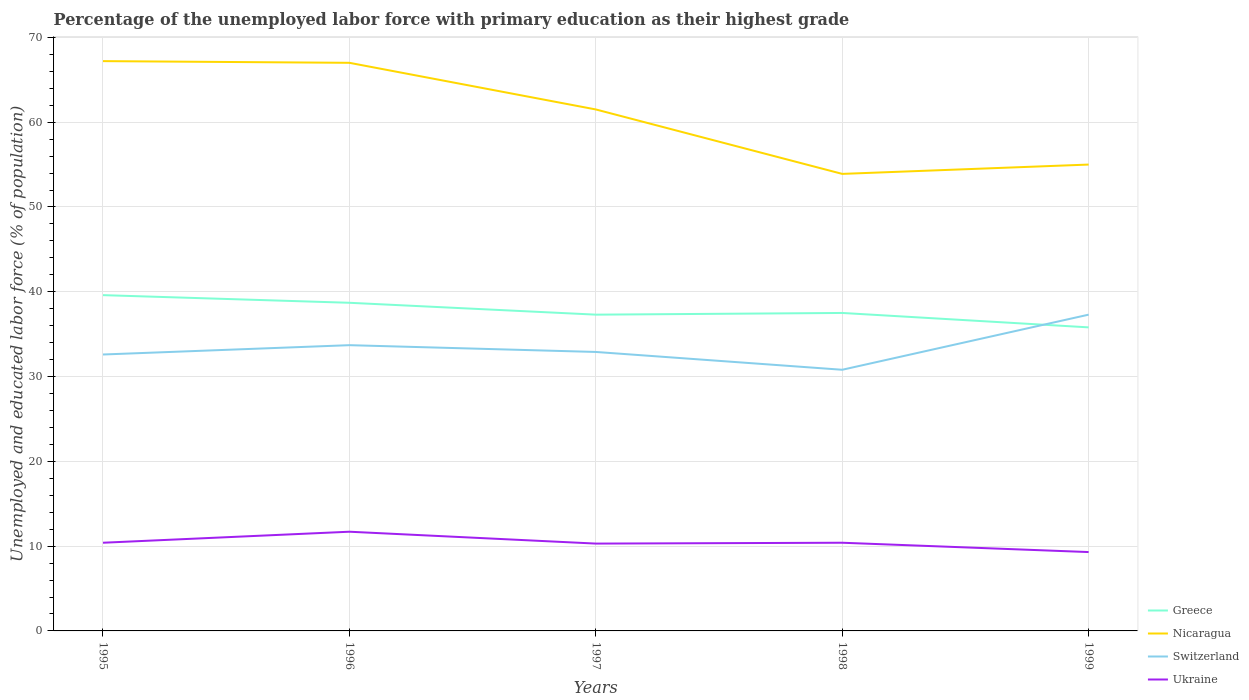Across all years, what is the maximum percentage of the unemployed labor force with primary education in Nicaragua?
Provide a short and direct response. 53.9. What is the total percentage of the unemployed labor force with primary education in Ukraine in the graph?
Your answer should be compact. 0.1. What is the difference between the highest and the second highest percentage of the unemployed labor force with primary education in Switzerland?
Your answer should be very brief. 6.5. What is the difference between the highest and the lowest percentage of the unemployed labor force with primary education in Ukraine?
Your response must be concise. 1. How many lines are there?
Offer a terse response. 4. How many years are there in the graph?
Offer a terse response. 5. Are the values on the major ticks of Y-axis written in scientific E-notation?
Offer a very short reply. No. Where does the legend appear in the graph?
Your answer should be very brief. Bottom right. What is the title of the graph?
Provide a short and direct response. Percentage of the unemployed labor force with primary education as their highest grade. Does "Burkina Faso" appear as one of the legend labels in the graph?
Provide a short and direct response. No. What is the label or title of the Y-axis?
Your answer should be very brief. Unemployed and educated labor force (% of population). What is the Unemployed and educated labor force (% of population) of Greece in 1995?
Make the answer very short. 39.6. What is the Unemployed and educated labor force (% of population) in Nicaragua in 1995?
Provide a succinct answer. 67.2. What is the Unemployed and educated labor force (% of population) in Switzerland in 1995?
Your answer should be very brief. 32.6. What is the Unemployed and educated labor force (% of population) of Ukraine in 1995?
Provide a succinct answer. 10.4. What is the Unemployed and educated labor force (% of population) of Greece in 1996?
Offer a terse response. 38.7. What is the Unemployed and educated labor force (% of population) in Nicaragua in 1996?
Your answer should be compact. 67. What is the Unemployed and educated labor force (% of population) of Switzerland in 1996?
Offer a very short reply. 33.7. What is the Unemployed and educated labor force (% of population) in Ukraine in 1996?
Offer a terse response. 11.7. What is the Unemployed and educated labor force (% of population) of Greece in 1997?
Your response must be concise. 37.3. What is the Unemployed and educated labor force (% of population) in Nicaragua in 1997?
Ensure brevity in your answer.  61.5. What is the Unemployed and educated labor force (% of population) in Switzerland in 1997?
Ensure brevity in your answer.  32.9. What is the Unemployed and educated labor force (% of population) of Ukraine in 1997?
Ensure brevity in your answer.  10.3. What is the Unemployed and educated labor force (% of population) in Greece in 1998?
Make the answer very short. 37.5. What is the Unemployed and educated labor force (% of population) in Nicaragua in 1998?
Provide a succinct answer. 53.9. What is the Unemployed and educated labor force (% of population) in Switzerland in 1998?
Make the answer very short. 30.8. What is the Unemployed and educated labor force (% of population) in Ukraine in 1998?
Offer a very short reply. 10.4. What is the Unemployed and educated labor force (% of population) of Greece in 1999?
Offer a very short reply. 35.8. What is the Unemployed and educated labor force (% of population) of Nicaragua in 1999?
Your answer should be compact. 55. What is the Unemployed and educated labor force (% of population) of Switzerland in 1999?
Provide a succinct answer. 37.3. What is the Unemployed and educated labor force (% of population) in Ukraine in 1999?
Provide a succinct answer. 9.3. Across all years, what is the maximum Unemployed and educated labor force (% of population) in Greece?
Provide a short and direct response. 39.6. Across all years, what is the maximum Unemployed and educated labor force (% of population) in Nicaragua?
Offer a terse response. 67.2. Across all years, what is the maximum Unemployed and educated labor force (% of population) in Switzerland?
Your response must be concise. 37.3. Across all years, what is the maximum Unemployed and educated labor force (% of population) in Ukraine?
Offer a terse response. 11.7. Across all years, what is the minimum Unemployed and educated labor force (% of population) in Greece?
Your response must be concise. 35.8. Across all years, what is the minimum Unemployed and educated labor force (% of population) of Nicaragua?
Your answer should be compact. 53.9. Across all years, what is the minimum Unemployed and educated labor force (% of population) of Switzerland?
Keep it short and to the point. 30.8. Across all years, what is the minimum Unemployed and educated labor force (% of population) in Ukraine?
Offer a terse response. 9.3. What is the total Unemployed and educated labor force (% of population) in Greece in the graph?
Offer a very short reply. 188.9. What is the total Unemployed and educated labor force (% of population) in Nicaragua in the graph?
Keep it short and to the point. 304.6. What is the total Unemployed and educated labor force (% of population) of Switzerland in the graph?
Make the answer very short. 167.3. What is the total Unemployed and educated labor force (% of population) in Ukraine in the graph?
Your response must be concise. 52.1. What is the difference between the Unemployed and educated labor force (% of population) of Nicaragua in 1995 and that in 1996?
Give a very brief answer. 0.2. What is the difference between the Unemployed and educated labor force (% of population) of Ukraine in 1995 and that in 1996?
Offer a terse response. -1.3. What is the difference between the Unemployed and educated labor force (% of population) of Greece in 1995 and that in 1997?
Your response must be concise. 2.3. What is the difference between the Unemployed and educated labor force (% of population) of Switzerland in 1995 and that in 1997?
Give a very brief answer. -0.3. What is the difference between the Unemployed and educated labor force (% of population) of Ukraine in 1995 and that in 1997?
Give a very brief answer. 0.1. What is the difference between the Unemployed and educated labor force (% of population) in Switzerland in 1995 and that in 1998?
Make the answer very short. 1.8. What is the difference between the Unemployed and educated labor force (% of population) in Greece in 1995 and that in 1999?
Give a very brief answer. 3.8. What is the difference between the Unemployed and educated labor force (% of population) of Switzerland in 1995 and that in 1999?
Give a very brief answer. -4.7. What is the difference between the Unemployed and educated labor force (% of population) in Ukraine in 1995 and that in 1999?
Provide a short and direct response. 1.1. What is the difference between the Unemployed and educated labor force (% of population) in Switzerland in 1996 and that in 1997?
Make the answer very short. 0.8. What is the difference between the Unemployed and educated labor force (% of population) in Ukraine in 1996 and that in 1997?
Offer a terse response. 1.4. What is the difference between the Unemployed and educated labor force (% of population) in Greece in 1996 and that in 1998?
Give a very brief answer. 1.2. What is the difference between the Unemployed and educated labor force (% of population) in Nicaragua in 1996 and that in 1998?
Offer a terse response. 13.1. What is the difference between the Unemployed and educated labor force (% of population) in Switzerland in 1996 and that in 1998?
Ensure brevity in your answer.  2.9. What is the difference between the Unemployed and educated labor force (% of population) of Ukraine in 1996 and that in 1998?
Offer a terse response. 1.3. What is the difference between the Unemployed and educated labor force (% of population) of Nicaragua in 1996 and that in 1999?
Offer a terse response. 12. What is the difference between the Unemployed and educated labor force (% of population) in Greece in 1997 and that in 1998?
Provide a short and direct response. -0.2. What is the difference between the Unemployed and educated labor force (% of population) of Ukraine in 1997 and that in 1998?
Provide a succinct answer. -0.1. What is the difference between the Unemployed and educated labor force (% of population) of Ukraine in 1997 and that in 1999?
Provide a short and direct response. 1. What is the difference between the Unemployed and educated labor force (% of population) in Greece in 1995 and the Unemployed and educated labor force (% of population) in Nicaragua in 1996?
Make the answer very short. -27.4. What is the difference between the Unemployed and educated labor force (% of population) of Greece in 1995 and the Unemployed and educated labor force (% of population) of Ukraine in 1996?
Keep it short and to the point. 27.9. What is the difference between the Unemployed and educated labor force (% of population) of Nicaragua in 1995 and the Unemployed and educated labor force (% of population) of Switzerland in 1996?
Give a very brief answer. 33.5. What is the difference between the Unemployed and educated labor force (% of population) in Nicaragua in 1995 and the Unemployed and educated labor force (% of population) in Ukraine in 1996?
Keep it short and to the point. 55.5. What is the difference between the Unemployed and educated labor force (% of population) of Switzerland in 1995 and the Unemployed and educated labor force (% of population) of Ukraine in 1996?
Your answer should be very brief. 20.9. What is the difference between the Unemployed and educated labor force (% of population) of Greece in 1995 and the Unemployed and educated labor force (% of population) of Nicaragua in 1997?
Make the answer very short. -21.9. What is the difference between the Unemployed and educated labor force (% of population) of Greece in 1995 and the Unemployed and educated labor force (% of population) of Switzerland in 1997?
Keep it short and to the point. 6.7. What is the difference between the Unemployed and educated labor force (% of population) of Greece in 1995 and the Unemployed and educated labor force (% of population) of Ukraine in 1997?
Provide a short and direct response. 29.3. What is the difference between the Unemployed and educated labor force (% of population) of Nicaragua in 1995 and the Unemployed and educated labor force (% of population) of Switzerland in 1997?
Your answer should be compact. 34.3. What is the difference between the Unemployed and educated labor force (% of population) in Nicaragua in 1995 and the Unemployed and educated labor force (% of population) in Ukraine in 1997?
Your answer should be very brief. 56.9. What is the difference between the Unemployed and educated labor force (% of population) in Switzerland in 1995 and the Unemployed and educated labor force (% of population) in Ukraine in 1997?
Make the answer very short. 22.3. What is the difference between the Unemployed and educated labor force (% of population) in Greece in 1995 and the Unemployed and educated labor force (% of population) in Nicaragua in 1998?
Your response must be concise. -14.3. What is the difference between the Unemployed and educated labor force (% of population) in Greece in 1995 and the Unemployed and educated labor force (% of population) in Ukraine in 1998?
Give a very brief answer. 29.2. What is the difference between the Unemployed and educated labor force (% of population) of Nicaragua in 1995 and the Unemployed and educated labor force (% of population) of Switzerland in 1998?
Ensure brevity in your answer.  36.4. What is the difference between the Unemployed and educated labor force (% of population) in Nicaragua in 1995 and the Unemployed and educated labor force (% of population) in Ukraine in 1998?
Your response must be concise. 56.8. What is the difference between the Unemployed and educated labor force (% of population) in Switzerland in 1995 and the Unemployed and educated labor force (% of population) in Ukraine in 1998?
Your response must be concise. 22.2. What is the difference between the Unemployed and educated labor force (% of population) of Greece in 1995 and the Unemployed and educated labor force (% of population) of Nicaragua in 1999?
Provide a succinct answer. -15.4. What is the difference between the Unemployed and educated labor force (% of population) of Greece in 1995 and the Unemployed and educated labor force (% of population) of Ukraine in 1999?
Keep it short and to the point. 30.3. What is the difference between the Unemployed and educated labor force (% of population) of Nicaragua in 1995 and the Unemployed and educated labor force (% of population) of Switzerland in 1999?
Provide a short and direct response. 29.9. What is the difference between the Unemployed and educated labor force (% of population) in Nicaragua in 1995 and the Unemployed and educated labor force (% of population) in Ukraine in 1999?
Make the answer very short. 57.9. What is the difference between the Unemployed and educated labor force (% of population) in Switzerland in 1995 and the Unemployed and educated labor force (% of population) in Ukraine in 1999?
Offer a very short reply. 23.3. What is the difference between the Unemployed and educated labor force (% of population) in Greece in 1996 and the Unemployed and educated labor force (% of population) in Nicaragua in 1997?
Provide a succinct answer. -22.8. What is the difference between the Unemployed and educated labor force (% of population) in Greece in 1996 and the Unemployed and educated labor force (% of population) in Ukraine in 1997?
Provide a succinct answer. 28.4. What is the difference between the Unemployed and educated labor force (% of population) of Nicaragua in 1996 and the Unemployed and educated labor force (% of population) of Switzerland in 1997?
Keep it short and to the point. 34.1. What is the difference between the Unemployed and educated labor force (% of population) of Nicaragua in 1996 and the Unemployed and educated labor force (% of population) of Ukraine in 1997?
Your response must be concise. 56.7. What is the difference between the Unemployed and educated labor force (% of population) of Switzerland in 1996 and the Unemployed and educated labor force (% of population) of Ukraine in 1997?
Keep it short and to the point. 23.4. What is the difference between the Unemployed and educated labor force (% of population) of Greece in 1996 and the Unemployed and educated labor force (% of population) of Nicaragua in 1998?
Provide a succinct answer. -15.2. What is the difference between the Unemployed and educated labor force (% of population) in Greece in 1996 and the Unemployed and educated labor force (% of population) in Switzerland in 1998?
Your answer should be compact. 7.9. What is the difference between the Unemployed and educated labor force (% of population) of Greece in 1996 and the Unemployed and educated labor force (% of population) of Ukraine in 1998?
Offer a very short reply. 28.3. What is the difference between the Unemployed and educated labor force (% of population) of Nicaragua in 1996 and the Unemployed and educated labor force (% of population) of Switzerland in 1998?
Provide a short and direct response. 36.2. What is the difference between the Unemployed and educated labor force (% of population) of Nicaragua in 1996 and the Unemployed and educated labor force (% of population) of Ukraine in 1998?
Provide a succinct answer. 56.6. What is the difference between the Unemployed and educated labor force (% of population) in Switzerland in 1996 and the Unemployed and educated labor force (% of population) in Ukraine in 1998?
Give a very brief answer. 23.3. What is the difference between the Unemployed and educated labor force (% of population) of Greece in 1996 and the Unemployed and educated labor force (% of population) of Nicaragua in 1999?
Make the answer very short. -16.3. What is the difference between the Unemployed and educated labor force (% of population) of Greece in 1996 and the Unemployed and educated labor force (% of population) of Ukraine in 1999?
Keep it short and to the point. 29.4. What is the difference between the Unemployed and educated labor force (% of population) of Nicaragua in 1996 and the Unemployed and educated labor force (% of population) of Switzerland in 1999?
Your answer should be very brief. 29.7. What is the difference between the Unemployed and educated labor force (% of population) in Nicaragua in 1996 and the Unemployed and educated labor force (% of population) in Ukraine in 1999?
Offer a very short reply. 57.7. What is the difference between the Unemployed and educated labor force (% of population) of Switzerland in 1996 and the Unemployed and educated labor force (% of population) of Ukraine in 1999?
Make the answer very short. 24.4. What is the difference between the Unemployed and educated labor force (% of population) of Greece in 1997 and the Unemployed and educated labor force (% of population) of Nicaragua in 1998?
Your answer should be very brief. -16.6. What is the difference between the Unemployed and educated labor force (% of population) of Greece in 1997 and the Unemployed and educated labor force (% of population) of Switzerland in 1998?
Give a very brief answer. 6.5. What is the difference between the Unemployed and educated labor force (% of population) of Greece in 1997 and the Unemployed and educated labor force (% of population) of Ukraine in 1998?
Offer a very short reply. 26.9. What is the difference between the Unemployed and educated labor force (% of population) in Nicaragua in 1997 and the Unemployed and educated labor force (% of population) in Switzerland in 1998?
Keep it short and to the point. 30.7. What is the difference between the Unemployed and educated labor force (% of population) in Nicaragua in 1997 and the Unemployed and educated labor force (% of population) in Ukraine in 1998?
Make the answer very short. 51.1. What is the difference between the Unemployed and educated labor force (% of population) of Greece in 1997 and the Unemployed and educated labor force (% of population) of Nicaragua in 1999?
Offer a terse response. -17.7. What is the difference between the Unemployed and educated labor force (% of population) in Nicaragua in 1997 and the Unemployed and educated labor force (% of population) in Switzerland in 1999?
Your answer should be compact. 24.2. What is the difference between the Unemployed and educated labor force (% of population) in Nicaragua in 1997 and the Unemployed and educated labor force (% of population) in Ukraine in 1999?
Offer a very short reply. 52.2. What is the difference between the Unemployed and educated labor force (% of population) of Switzerland in 1997 and the Unemployed and educated labor force (% of population) of Ukraine in 1999?
Make the answer very short. 23.6. What is the difference between the Unemployed and educated labor force (% of population) in Greece in 1998 and the Unemployed and educated labor force (% of population) in Nicaragua in 1999?
Provide a short and direct response. -17.5. What is the difference between the Unemployed and educated labor force (% of population) in Greece in 1998 and the Unemployed and educated labor force (% of population) in Ukraine in 1999?
Keep it short and to the point. 28.2. What is the difference between the Unemployed and educated labor force (% of population) in Nicaragua in 1998 and the Unemployed and educated labor force (% of population) in Ukraine in 1999?
Provide a succinct answer. 44.6. What is the average Unemployed and educated labor force (% of population) of Greece per year?
Keep it short and to the point. 37.78. What is the average Unemployed and educated labor force (% of population) in Nicaragua per year?
Provide a short and direct response. 60.92. What is the average Unemployed and educated labor force (% of population) of Switzerland per year?
Provide a short and direct response. 33.46. What is the average Unemployed and educated labor force (% of population) in Ukraine per year?
Offer a very short reply. 10.42. In the year 1995, what is the difference between the Unemployed and educated labor force (% of population) in Greece and Unemployed and educated labor force (% of population) in Nicaragua?
Make the answer very short. -27.6. In the year 1995, what is the difference between the Unemployed and educated labor force (% of population) of Greece and Unemployed and educated labor force (% of population) of Ukraine?
Keep it short and to the point. 29.2. In the year 1995, what is the difference between the Unemployed and educated labor force (% of population) in Nicaragua and Unemployed and educated labor force (% of population) in Switzerland?
Keep it short and to the point. 34.6. In the year 1995, what is the difference between the Unemployed and educated labor force (% of population) of Nicaragua and Unemployed and educated labor force (% of population) of Ukraine?
Provide a succinct answer. 56.8. In the year 1996, what is the difference between the Unemployed and educated labor force (% of population) of Greece and Unemployed and educated labor force (% of population) of Nicaragua?
Give a very brief answer. -28.3. In the year 1996, what is the difference between the Unemployed and educated labor force (% of population) in Greece and Unemployed and educated labor force (% of population) in Switzerland?
Your answer should be very brief. 5. In the year 1996, what is the difference between the Unemployed and educated labor force (% of population) of Nicaragua and Unemployed and educated labor force (% of population) of Switzerland?
Your response must be concise. 33.3. In the year 1996, what is the difference between the Unemployed and educated labor force (% of population) of Nicaragua and Unemployed and educated labor force (% of population) of Ukraine?
Offer a terse response. 55.3. In the year 1996, what is the difference between the Unemployed and educated labor force (% of population) of Switzerland and Unemployed and educated labor force (% of population) of Ukraine?
Provide a succinct answer. 22. In the year 1997, what is the difference between the Unemployed and educated labor force (% of population) of Greece and Unemployed and educated labor force (% of population) of Nicaragua?
Your answer should be compact. -24.2. In the year 1997, what is the difference between the Unemployed and educated labor force (% of population) in Greece and Unemployed and educated labor force (% of population) in Switzerland?
Offer a very short reply. 4.4. In the year 1997, what is the difference between the Unemployed and educated labor force (% of population) in Greece and Unemployed and educated labor force (% of population) in Ukraine?
Give a very brief answer. 27. In the year 1997, what is the difference between the Unemployed and educated labor force (% of population) in Nicaragua and Unemployed and educated labor force (% of population) in Switzerland?
Provide a short and direct response. 28.6. In the year 1997, what is the difference between the Unemployed and educated labor force (% of population) of Nicaragua and Unemployed and educated labor force (% of population) of Ukraine?
Provide a succinct answer. 51.2. In the year 1997, what is the difference between the Unemployed and educated labor force (% of population) of Switzerland and Unemployed and educated labor force (% of population) of Ukraine?
Offer a terse response. 22.6. In the year 1998, what is the difference between the Unemployed and educated labor force (% of population) of Greece and Unemployed and educated labor force (% of population) of Nicaragua?
Keep it short and to the point. -16.4. In the year 1998, what is the difference between the Unemployed and educated labor force (% of population) in Greece and Unemployed and educated labor force (% of population) in Switzerland?
Offer a very short reply. 6.7. In the year 1998, what is the difference between the Unemployed and educated labor force (% of population) in Greece and Unemployed and educated labor force (% of population) in Ukraine?
Make the answer very short. 27.1. In the year 1998, what is the difference between the Unemployed and educated labor force (% of population) of Nicaragua and Unemployed and educated labor force (% of population) of Switzerland?
Keep it short and to the point. 23.1. In the year 1998, what is the difference between the Unemployed and educated labor force (% of population) of Nicaragua and Unemployed and educated labor force (% of population) of Ukraine?
Provide a succinct answer. 43.5. In the year 1998, what is the difference between the Unemployed and educated labor force (% of population) of Switzerland and Unemployed and educated labor force (% of population) of Ukraine?
Provide a short and direct response. 20.4. In the year 1999, what is the difference between the Unemployed and educated labor force (% of population) in Greece and Unemployed and educated labor force (% of population) in Nicaragua?
Provide a short and direct response. -19.2. In the year 1999, what is the difference between the Unemployed and educated labor force (% of population) of Nicaragua and Unemployed and educated labor force (% of population) of Switzerland?
Offer a very short reply. 17.7. In the year 1999, what is the difference between the Unemployed and educated labor force (% of population) in Nicaragua and Unemployed and educated labor force (% of population) in Ukraine?
Offer a terse response. 45.7. What is the ratio of the Unemployed and educated labor force (% of population) in Greece in 1995 to that in 1996?
Make the answer very short. 1.02. What is the ratio of the Unemployed and educated labor force (% of population) in Nicaragua in 1995 to that in 1996?
Ensure brevity in your answer.  1. What is the ratio of the Unemployed and educated labor force (% of population) of Switzerland in 1995 to that in 1996?
Your response must be concise. 0.97. What is the ratio of the Unemployed and educated labor force (% of population) in Greece in 1995 to that in 1997?
Provide a short and direct response. 1.06. What is the ratio of the Unemployed and educated labor force (% of population) of Nicaragua in 1995 to that in 1997?
Provide a short and direct response. 1.09. What is the ratio of the Unemployed and educated labor force (% of population) in Switzerland in 1995 to that in 1997?
Give a very brief answer. 0.99. What is the ratio of the Unemployed and educated labor force (% of population) of Ukraine in 1995 to that in 1997?
Offer a very short reply. 1.01. What is the ratio of the Unemployed and educated labor force (% of population) of Greece in 1995 to that in 1998?
Provide a short and direct response. 1.06. What is the ratio of the Unemployed and educated labor force (% of population) in Nicaragua in 1995 to that in 1998?
Your answer should be compact. 1.25. What is the ratio of the Unemployed and educated labor force (% of population) in Switzerland in 1995 to that in 1998?
Offer a terse response. 1.06. What is the ratio of the Unemployed and educated labor force (% of population) of Ukraine in 1995 to that in 1998?
Provide a succinct answer. 1. What is the ratio of the Unemployed and educated labor force (% of population) of Greece in 1995 to that in 1999?
Provide a succinct answer. 1.11. What is the ratio of the Unemployed and educated labor force (% of population) of Nicaragua in 1995 to that in 1999?
Make the answer very short. 1.22. What is the ratio of the Unemployed and educated labor force (% of population) of Switzerland in 1995 to that in 1999?
Make the answer very short. 0.87. What is the ratio of the Unemployed and educated labor force (% of population) of Ukraine in 1995 to that in 1999?
Your answer should be very brief. 1.12. What is the ratio of the Unemployed and educated labor force (% of population) of Greece in 1996 to that in 1997?
Offer a terse response. 1.04. What is the ratio of the Unemployed and educated labor force (% of population) in Nicaragua in 1996 to that in 1997?
Give a very brief answer. 1.09. What is the ratio of the Unemployed and educated labor force (% of population) of Switzerland in 1996 to that in 1997?
Your answer should be very brief. 1.02. What is the ratio of the Unemployed and educated labor force (% of population) in Ukraine in 1996 to that in 1997?
Provide a short and direct response. 1.14. What is the ratio of the Unemployed and educated labor force (% of population) of Greece in 1996 to that in 1998?
Make the answer very short. 1.03. What is the ratio of the Unemployed and educated labor force (% of population) of Nicaragua in 1996 to that in 1998?
Your answer should be compact. 1.24. What is the ratio of the Unemployed and educated labor force (% of population) in Switzerland in 1996 to that in 1998?
Ensure brevity in your answer.  1.09. What is the ratio of the Unemployed and educated labor force (% of population) in Greece in 1996 to that in 1999?
Your response must be concise. 1.08. What is the ratio of the Unemployed and educated labor force (% of population) in Nicaragua in 1996 to that in 1999?
Keep it short and to the point. 1.22. What is the ratio of the Unemployed and educated labor force (% of population) in Switzerland in 1996 to that in 1999?
Your response must be concise. 0.9. What is the ratio of the Unemployed and educated labor force (% of population) of Ukraine in 1996 to that in 1999?
Offer a very short reply. 1.26. What is the ratio of the Unemployed and educated labor force (% of population) of Nicaragua in 1997 to that in 1998?
Your answer should be very brief. 1.14. What is the ratio of the Unemployed and educated labor force (% of population) of Switzerland in 1997 to that in 1998?
Your answer should be compact. 1.07. What is the ratio of the Unemployed and educated labor force (% of population) of Greece in 1997 to that in 1999?
Keep it short and to the point. 1.04. What is the ratio of the Unemployed and educated labor force (% of population) in Nicaragua in 1997 to that in 1999?
Give a very brief answer. 1.12. What is the ratio of the Unemployed and educated labor force (% of population) of Switzerland in 1997 to that in 1999?
Provide a short and direct response. 0.88. What is the ratio of the Unemployed and educated labor force (% of population) in Ukraine in 1997 to that in 1999?
Your answer should be compact. 1.11. What is the ratio of the Unemployed and educated labor force (% of population) of Greece in 1998 to that in 1999?
Keep it short and to the point. 1.05. What is the ratio of the Unemployed and educated labor force (% of population) in Nicaragua in 1998 to that in 1999?
Keep it short and to the point. 0.98. What is the ratio of the Unemployed and educated labor force (% of population) of Switzerland in 1998 to that in 1999?
Offer a very short reply. 0.83. What is the ratio of the Unemployed and educated labor force (% of population) of Ukraine in 1998 to that in 1999?
Make the answer very short. 1.12. What is the difference between the highest and the second highest Unemployed and educated labor force (% of population) in Nicaragua?
Your answer should be compact. 0.2. What is the difference between the highest and the second highest Unemployed and educated labor force (% of population) in Switzerland?
Keep it short and to the point. 3.6. What is the difference between the highest and the second highest Unemployed and educated labor force (% of population) of Ukraine?
Give a very brief answer. 1.3. What is the difference between the highest and the lowest Unemployed and educated labor force (% of population) of Greece?
Provide a short and direct response. 3.8. What is the difference between the highest and the lowest Unemployed and educated labor force (% of population) in Nicaragua?
Your answer should be compact. 13.3. What is the difference between the highest and the lowest Unemployed and educated labor force (% of population) in Switzerland?
Ensure brevity in your answer.  6.5. 